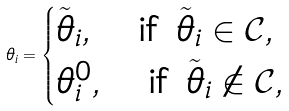<formula> <loc_0><loc_0><loc_500><loc_500>\theta _ { i } = \begin{cases} \tilde { \theta } _ { i } , \quad \text {if } \tilde { \theta } _ { i } \in \mathcal { C } , \\ \theta _ { i } ^ { 0 } , \quad \text {if } \tilde { \theta } _ { i } \notin \mathcal { C } , \end{cases}</formula> 